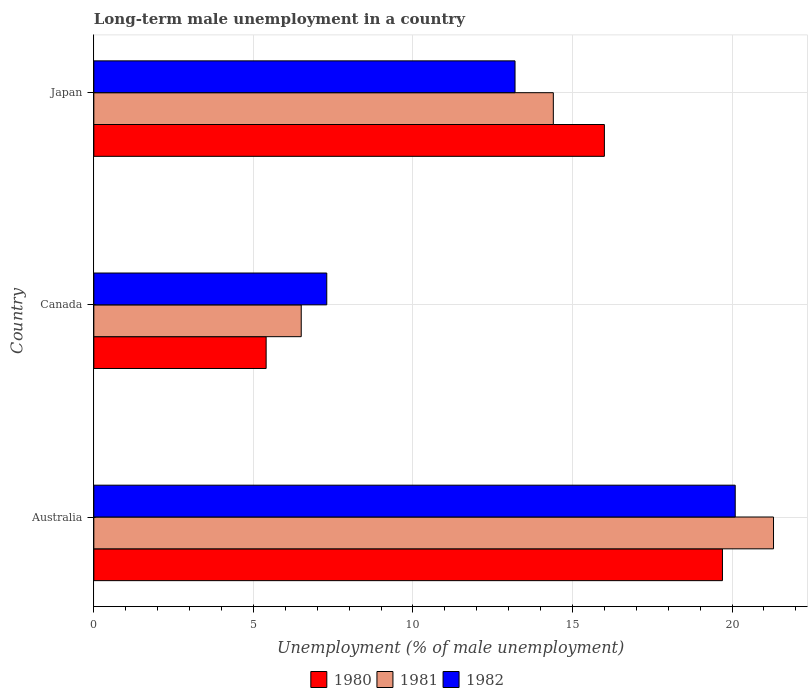How many groups of bars are there?
Offer a very short reply. 3. Are the number of bars per tick equal to the number of legend labels?
Ensure brevity in your answer.  Yes. How many bars are there on the 2nd tick from the bottom?
Your response must be concise. 3. In how many cases, is the number of bars for a given country not equal to the number of legend labels?
Your answer should be very brief. 0. What is the percentage of long-term unemployed male population in 1981 in Australia?
Offer a very short reply. 21.3. Across all countries, what is the maximum percentage of long-term unemployed male population in 1982?
Offer a terse response. 20.1. Across all countries, what is the minimum percentage of long-term unemployed male population in 1982?
Your answer should be compact. 7.3. What is the total percentage of long-term unemployed male population in 1980 in the graph?
Make the answer very short. 41.1. What is the difference between the percentage of long-term unemployed male population in 1981 in Australia and that in Japan?
Keep it short and to the point. 6.9. What is the difference between the percentage of long-term unemployed male population in 1982 in Japan and the percentage of long-term unemployed male population in 1980 in Canada?
Give a very brief answer. 7.8. What is the average percentage of long-term unemployed male population in 1981 per country?
Make the answer very short. 14.07. What is the difference between the percentage of long-term unemployed male population in 1982 and percentage of long-term unemployed male population in 1981 in Japan?
Your answer should be compact. -1.2. In how many countries, is the percentage of long-term unemployed male population in 1980 greater than 1 %?
Offer a very short reply. 3. What is the ratio of the percentage of long-term unemployed male population in 1980 in Australia to that in Canada?
Offer a terse response. 3.65. Is the difference between the percentage of long-term unemployed male population in 1982 in Australia and Canada greater than the difference between the percentage of long-term unemployed male population in 1981 in Australia and Canada?
Provide a short and direct response. No. What is the difference between the highest and the second highest percentage of long-term unemployed male population in 1982?
Offer a terse response. 6.9. What is the difference between the highest and the lowest percentage of long-term unemployed male population in 1981?
Your answer should be compact. 14.8. In how many countries, is the percentage of long-term unemployed male population in 1982 greater than the average percentage of long-term unemployed male population in 1982 taken over all countries?
Keep it short and to the point. 1. Is the sum of the percentage of long-term unemployed male population in 1980 in Australia and Japan greater than the maximum percentage of long-term unemployed male population in 1982 across all countries?
Provide a short and direct response. Yes. How many bars are there?
Your answer should be compact. 9. Are all the bars in the graph horizontal?
Ensure brevity in your answer.  Yes. How many countries are there in the graph?
Give a very brief answer. 3. Are the values on the major ticks of X-axis written in scientific E-notation?
Keep it short and to the point. No. Does the graph contain any zero values?
Your answer should be very brief. No. Does the graph contain grids?
Your response must be concise. Yes. How are the legend labels stacked?
Offer a terse response. Horizontal. What is the title of the graph?
Your response must be concise. Long-term male unemployment in a country. What is the label or title of the X-axis?
Keep it short and to the point. Unemployment (% of male unemployment). What is the label or title of the Y-axis?
Your answer should be compact. Country. What is the Unemployment (% of male unemployment) in 1980 in Australia?
Offer a very short reply. 19.7. What is the Unemployment (% of male unemployment) in 1981 in Australia?
Keep it short and to the point. 21.3. What is the Unemployment (% of male unemployment) of 1982 in Australia?
Provide a succinct answer. 20.1. What is the Unemployment (% of male unemployment) of 1980 in Canada?
Your response must be concise. 5.4. What is the Unemployment (% of male unemployment) in 1981 in Canada?
Keep it short and to the point. 6.5. What is the Unemployment (% of male unemployment) of 1982 in Canada?
Give a very brief answer. 7.3. What is the Unemployment (% of male unemployment) in 1981 in Japan?
Provide a succinct answer. 14.4. What is the Unemployment (% of male unemployment) of 1982 in Japan?
Make the answer very short. 13.2. Across all countries, what is the maximum Unemployment (% of male unemployment) in 1980?
Your answer should be compact. 19.7. Across all countries, what is the maximum Unemployment (% of male unemployment) of 1981?
Your answer should be very brief. 21.3. Across all countries, what is the maximum Unemployment (% of male unemployment) of 1982?
Your answer should be compact. 20.1. Across all countries, what is the minimum Unemployment (% of male unemployment) of 1980?
Offer a very short reply. 5.4. Across all countries, what is the minimum Unemployment (% of male unemployment) of 1981?
Provide a short and direct response. 6.5. Across all countries, what is the minimum Unemployment (% of male unemployment) of 1982?
Your response must be concise. 7.3. What is the total Unemployment (% of male unemployment) in 1980 in the graph?
Provide a succinct answer. 41.1. What is the total Unemployment (% of male unemployment) of 1981 in the graph?
Offer a very short reply. 42.2. What is the total Unemployment (% of male unemployment) of 1982 in the graph?
Provide a succinct answer. 40.6. What is the difference between the Unemployment (% of male unemployment) in 1980 in Australia and that in Canada?
Offer a very short reply. 14.3. What is the difference between the Unemployment (% of male unemployment) of 1982 in Australia and that in Canada?
Your answer should be very brief. 12.8. What is the difference between the Unemployment (% of male unemployment) in 1981 in Australia and that in Japan?
Keep it short and to the point. 6.9. What is the difference between the Unemployment (% of male unemployment) in 1982 in Australia and that in Japan?
Make the answer very short. 6.9. What is the difference between the Unemployment (% of male unemployment) of 1980 in Canada and that in Japan?
Offer a very short reply. -10.6. What is the difference between the Unemployment (% of male unemployment) in 1981 in Australia and the Unemployment (% of male unemployment) in 1982 in Canada?
Offer a very short reply. 14. What is the difference between the Unemployment (% of male unemployment) in 1980 in Australia and the Unemployment (% of male unemployment) in 1982 in Japan?
Your answer should be compact. 6.5. What is the difference between the Unemployment (% of male unemployment) in 1981 in Australia and the Unemployment (% of male unemployment) in 1982 in Japan?
Offer a very short reply. 8.1. What is the difference between the Unemployment (% of male unemployment) of 1980 in Canada and the Unemployment (% of male unemployment) of 1981 in Japan?
Provide a short and direct response. -9. What is the difference between the Unemployment (% of male unemployment) of 1980 in Canada and the Unemployment (% of male unemployment) of 1982 in Japan?
Offer a terse response. -7.8. What is the average Unemployment (% of male unemployment) in 1981 per country?
Provide a short and direct response. 14.07. What is the average Unemployment (% of male unemployment) of 1982 per country?
Keep it short and to the point. 13.53. What is the difference between the Unemployment (% of male unemployment) of 1980 and Unemployment (% of male unemployment) of 1981 in Australia?
Make the answer very short. -1.6. What is the difference between the Unemployment (% of male unemployment) in 1980 and Unemployment (% of male unemployment) in 1982 in Australia?
Offer a terse response. -0.4. What is the difference between the Unemployment (% of male unemployment) in 1981 and Unemployment (% of male unemployment) in 1982 in Australia?
Give a very brief answer. 1.2. What is the difference between the Unemployment (% of male unemployment) in 1981 and Unemployment (% of male unemployment) in 1982 in Canada?
Your answer should be very brief. -0.8. What is the ratio of the Unemployment (% of male unemployment) in 1980 in Australia to that in Canada?
Your response must be concise. 3.65. What is the ratio of the Unemployment (% of male unemployment) in 1981 in Australia to that in Canada?
Keep it short and to the point. 3.28. What is the ratio of the Unemployment (% of male unemployment) of 1982 in Australia to that in Canada?
Offer a very short reply. 2.75. What is the ratio of the Unemployment (% of male unemployment) of 1980 in Australia to that in Japan?
Your answer should be very brief. 1.23. What is the ratio of the Unemployment (% of male unemployment) in 1981 in Australia to that in Japan?
Your response must be concise. 1.48. What is the ratio of the Unemployment (% of male unemployment) of 1982 in Australia to that in Japan?
Offer a terse response. 1.52. What is the ratio of the Unemployment (% of male unemployment) in 1980 in Canada to that in Japan?
Give a very brief answer. 0.34. What is the ratio of the Unemployment (% of male unemployment) in 1981 in Canada to that in Japan?
Make the answer very short. 0.45. What is the ratio of the Unemployment (% of male unemployment) of 1982 in Canada to that in Japan?
Offer a very short reply. 0.55. What is the difference between the highest and the second highest Unemployment (% of male unemployment) of 1982?
Ensure brevity in your answer.  6.9. What is the difference between the highest and the lowest Unemployment (% of male unemployment) of 1980?
Provide a succinct answer. 14.3. 